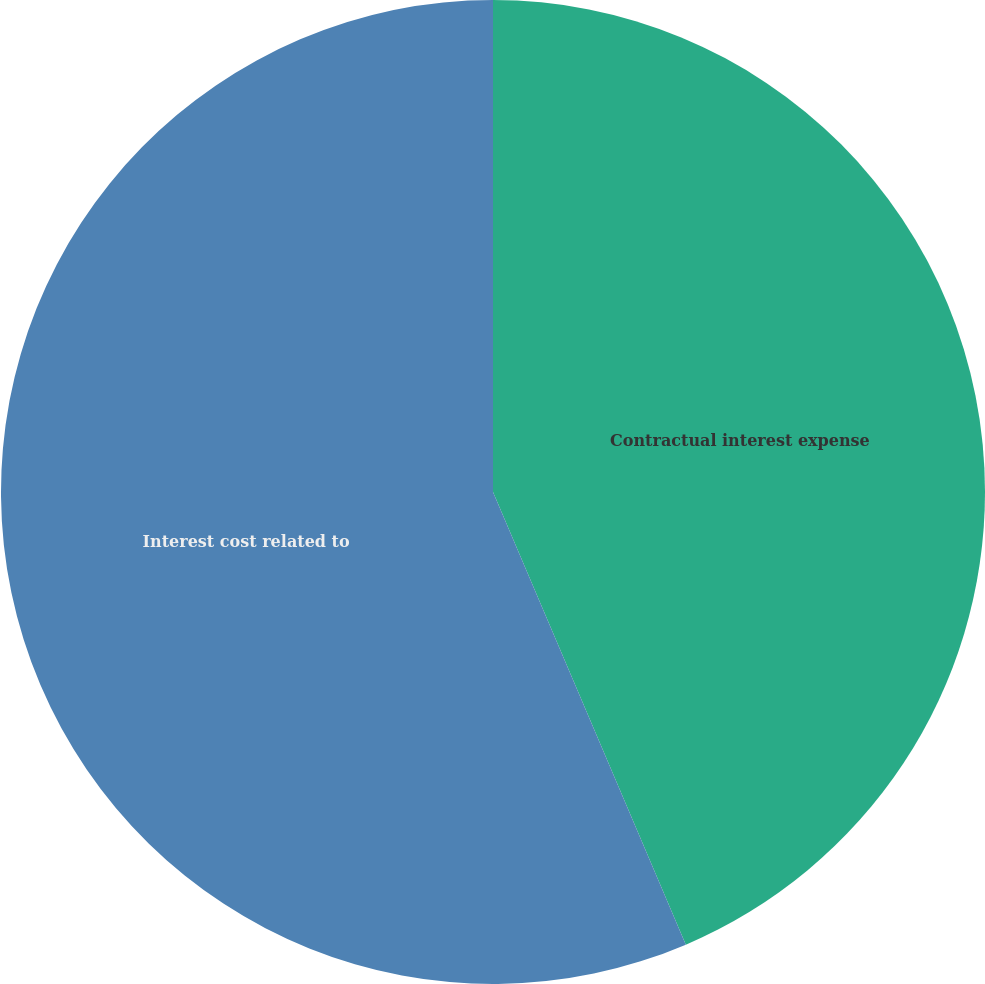Convert chart to OTSL. <chart><loc_0><loc_0><loc_500><loc_500><pie_chart><fcel>Contractual interest expense<fcel>Interest cost related to<nl><fcel>43.59%<fcel>56.41%<nl></chart> 